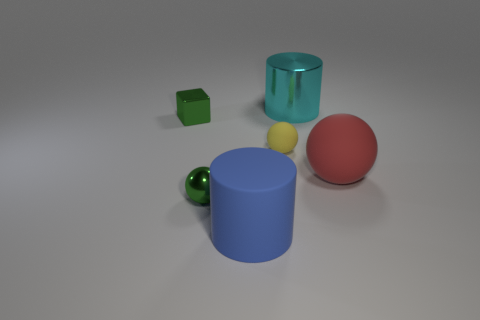Is the number of yellow matte objects less than the number of brown cylinders?
Give a very brief answer. No. The green metal thing that is behind the small green thing that is in front of the small yellow matte ball is what shape?
Keep it short and to the point. Cube. Is there anything else that has the same size as the blue cylinder?
Your answer should be very brief. Yes. What shape is the rubber thing on the right side of the small yellow thing behind the blue matte cylinder that is to the right of the tiny green cube?
Offer a very short reply. Sphere. How many objects are green blocks that are behind the red sphere or small balls that are behind the green ball?
Make the answer very short. 2. There is a green block; is its size the same as the cylinder left of the large cyan metallic cylinder?
Your response must be concise. No. Are the ball to the right of the cyan thing and the big cylinder that is in front of the large metal thing made of the same material?
Your answer should be very brief. Yes. Are there the same number of yellow spheres that are in front of the tiny yellow matte thing and large cylinders that are left of the shiny cylinder?
Give a very brief answer. No. How many cylinders are the same color as the large sphere?
Keep it short and to the point. 0. What material is the cube that is the same color as the metal ball?
Make the answer very short. Metal. 